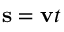Convert formula to latex. <formula><loc_0><loc_0><loc_500><loc_500>s = v t</formula> 